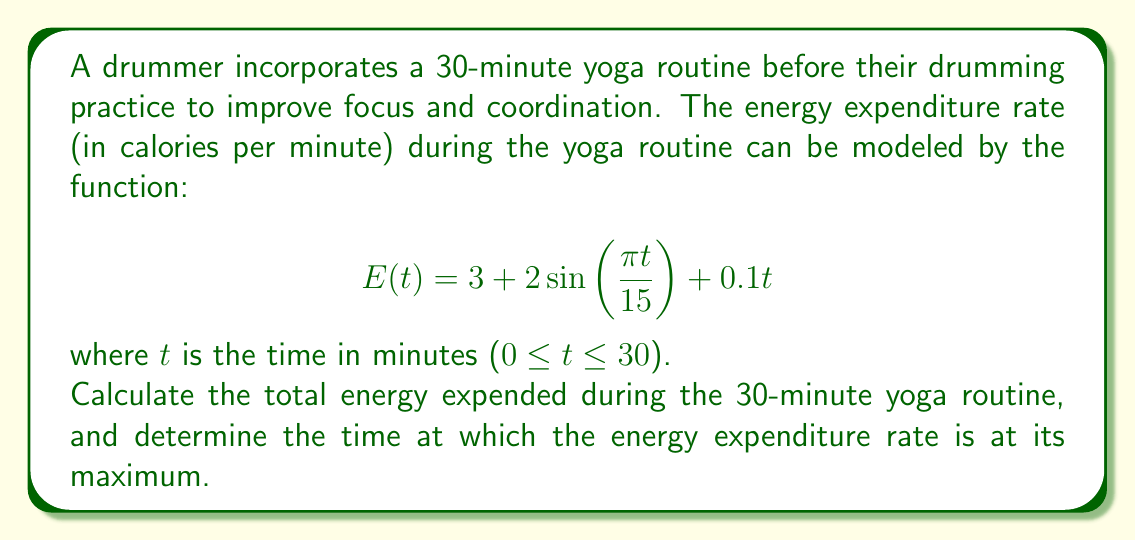Can you answer this question? To solve this problem, we'll use calculus techniques for integration and optimization.

1. Total energy expended:
To find the total energy expended, we need to integrate the energy expenditure rate function over the 30-minute period:

$$\text{Total Energy} = \int_0^{30} E(t) dt = \int_0^{30} (3 + 2\sin(\frac{\pi t}{15}) + 0.1t) dt$$

Let's integrate each term separately:

a) $\int_0^{30} 3 dt = 3t \big|_0^{30} = 90$

b) $\int_0^{30} 2\sin(\frac{\pi t}{15}) dt = -\frac{30}{\pi} \cdot 2\cos(\frac{\pi t}{15}) \big|_0^{30} = -\frac{60}{\pi}(\cos(2\pi) - \cos(0)) = 0$

c) $\int_0^{30} 0.1t dt = 0.05t^2 \big|_0^{30} = 0.05(900) = 45$

Total Energy = 90 + 0 + 45 = 135 calories

2. Maximum energy expenditure rate:
To find the time at which the energy expenditure rate is at its maximum, we need to find the critical points of E(t) by taking its derivative and setting it equal to zero:

$$E'(t) = \frac{2\pi}{15}\cos(\frac{\pi t}{15}) + 0.1$$

Set $E'(t) = 0$:

$$\frac{2\pi}{15}\cos(\frac{\pi t}{15}) + 0.1 = 0$$
$$\cos(\frac{\pi t}{15}) = -\frac{0.75}{\pi}$$
$$\frac{\pi t}{15} = \arccos(-\frac{0.75}{\pi})$$
$$t = \frac{15}{\pi} \arccos(-\frac{0.75}{\pi}) \approx 7.5 \text{ minutes}$$

To confirm this is a maximum, we can check the second derivative:

$$E''(t) = -\frac{2\pi^2}{225}\sin(\frac{\pi t}{15})$$

At t ≈ 7.5, $E''(7.5) < 0$, confirming it's a local maximum.

The other critical point occurs at t ≈ 22.5 minutes, which is a local minimum.
Answer: The total energy expended during the 30-minute yoga routine is 135 calories. The energy expenditure rate reaches its maximum at approximately 7.5 minutes into the routine. 